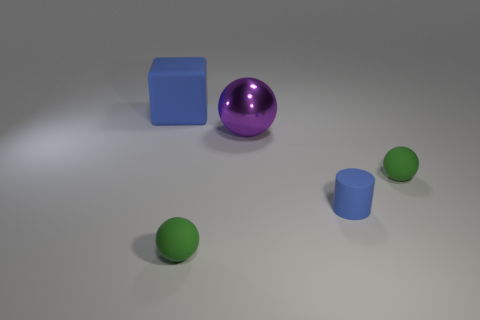If you could give this image a title that encapsulates its essence, what would it be? I would title this serene and simple scene 'Geometric Tranquility'. It captures a moment of quiet among variously shaped objects with subdued colors, all resting under a gentle light. 